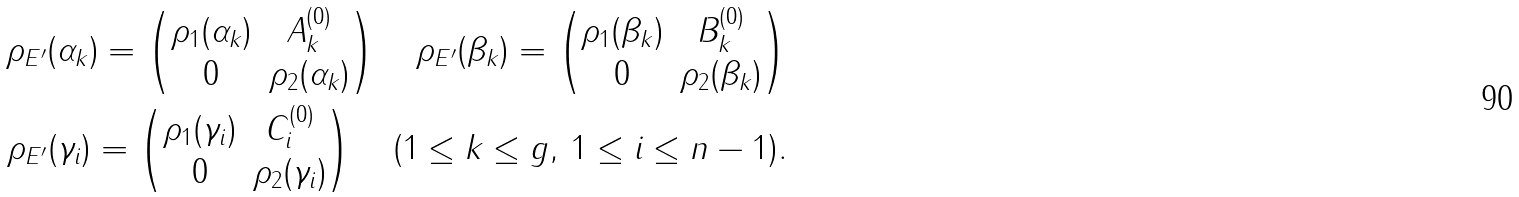<formula> <loc_0><loc_0><loc_500><loc_500>\rho _ { E ^ { \prime } } ( \alpha _ { k } ) = \begin{pmatrix} \rho _ { 1 } ( \alpha _ { k } ) & A ^ { ( 0 ) } _ { k } \\ 0 & \rho _ { 2 } ( \alpha _ { k } ) \end{pmatrix} \quad \rho _ { E ^ { \prime } } ( \beta _ { k } ) = \begin{pmatrix} \rho _ { 1 } ( \beta _ { k } ) & B ^ { ( 0 ) } _ { k } \\ 0 & \rho _ { 2 } ( \beta _ { k } ) \end{pmatrix} \\ \rho _ { E ^ { \prime } } ( \gamma _ { i } ) = \begin{pmatrix} \rho _ { 1 } ( \gamma _ { i } ) & C ^ { ( 0 ) } _ { i } \\ 0 & \rho _ { 2 } ( \gamma _ { i } ) \end{pmatrix} \quad ( 1 \leq k \leq g , \, 1 \leq i \leq n - 1 ) .</formula> 